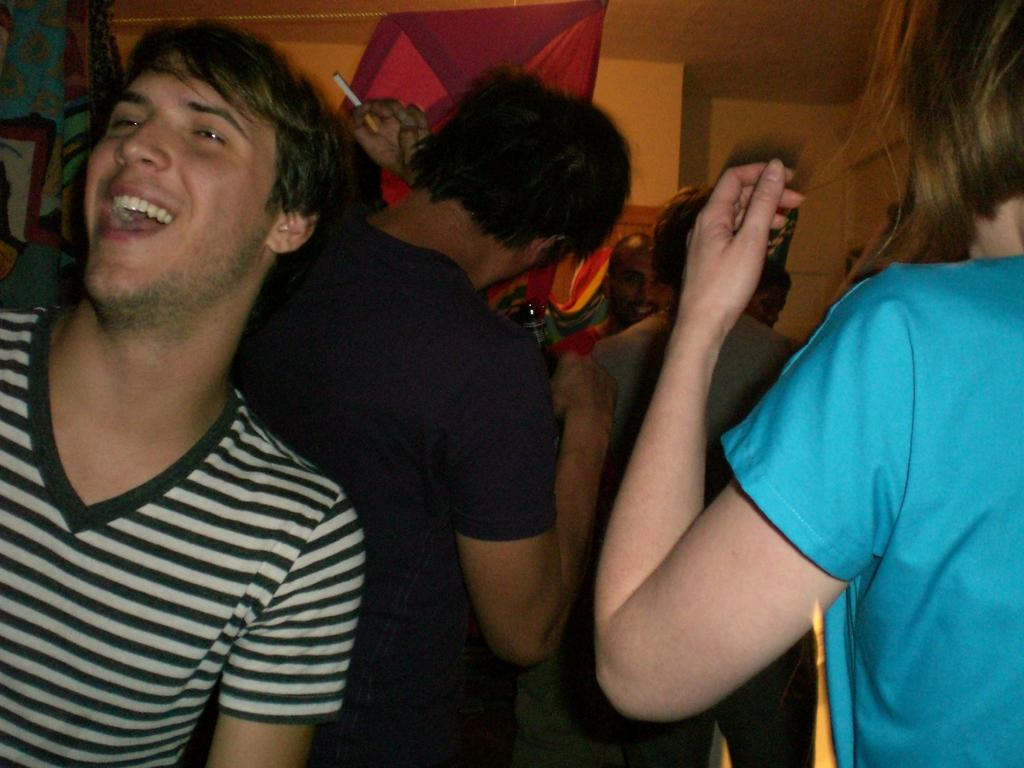What are the people in the image doing? The people in the image are standing near a wall. What can be seen on a surface in the image? There are objects on a surface in the image. What is one man holding in the image? One man is holding a bottle in the image. What is another man holding in the image? One man is holding a cigarette. Can you see any clovers growing near the wall in the image? There are no clovers visible in the image. Is the man holding a cigarette actually your uncle in the image? The man holding a cigarette is not identified as a specific person, so we cannot determine if he is your uncle. 